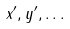<formula> <loc_0><loc_0><loc_500><loc_500>x ^ { \prime } , y ^ { \prime } , \dots</formula> 